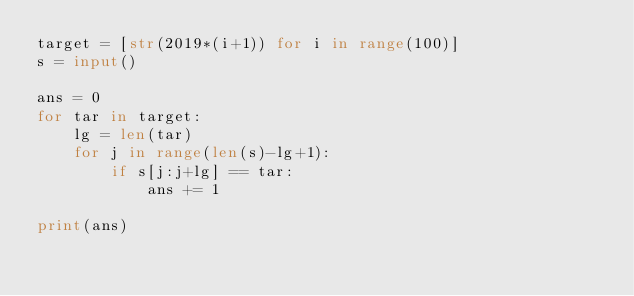Convert code to text. <code><loc_0><loc_0><loc_500><loc_500><_Python_>target = [str(2019*(i+1)) for i in range(100)]
s = input()

ans = 0
for tar in target:
    lg = len(tar)
    for j in range(len(s)-lg+1):
        if s[j:j+lg] == tar:
            ans += 1

print(ans)</code> 